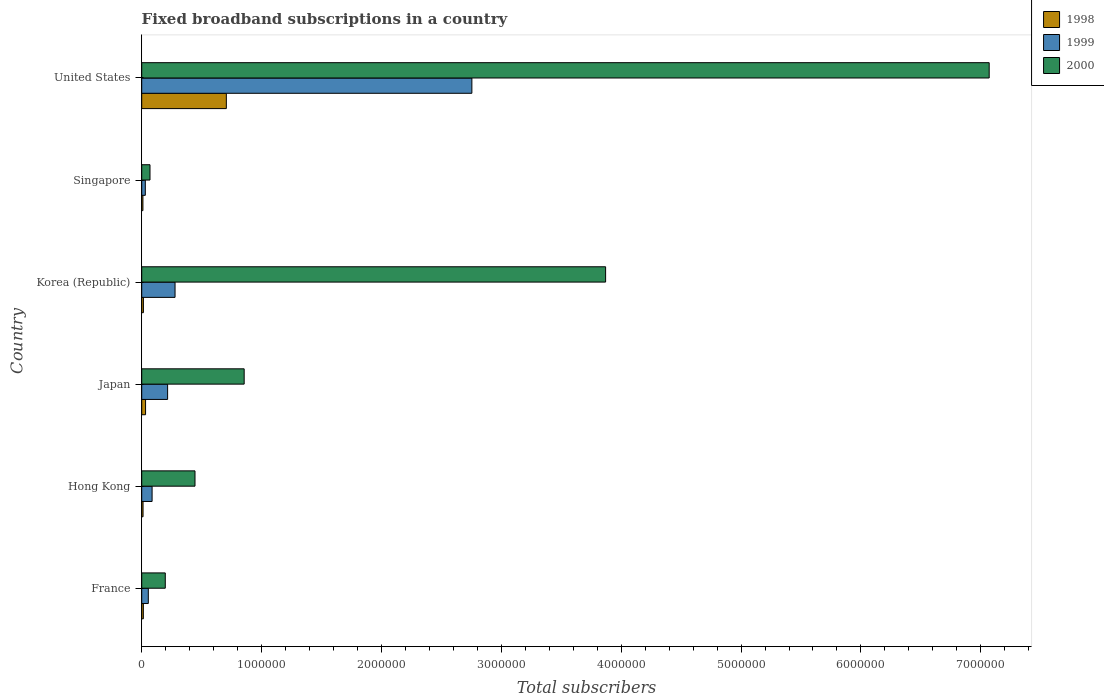How many groups of bars are there?
Provide a short and direct response. 6. Are the number of bars on each tick of the Y-axis equal?
Keep it short and to the point. Yes. How many bars are there on the 1st tick from the top?
Offer a very short reply. 3. How many bars are there on the 4th tick from the bottom?
Provide a succinct answer. 3. What is the number of broadband subscriptions in 1999 in Korea (Republic)?
Provide a short and direct response. 2.78e+05. Across all countries, what is the maximum number of broadband subscriptions in 2000?
Provide a succinct answer. 7.07e+06. Across all countries, what is the minimum number of broadband subscriptions in 2000?
Give a very brief answer. 6.90e+04. In which country was the number of broadband subscriptions in 1998 minimum?
Make the answer very short. Singapore. What is the total number of broadband subscriptions in 2000 in the graph?
Ensure brevity in your answer.  1.25e+07. What is the difference between the number of broadband subscriptions in 1998 in France and that in Korea (Republic)?
Your answer should be compact. -536. What is the difference between the number of broadband subscriptions in 2000 in Hong Kong and the number of broadband subscriptions in 1999 in Korea (Republic)?
Provide a succinct answer. 1.66e+05. What is the average number of broadband subscriptions in 2000 per country?
Give a very brief answer. 2.08e+06. What is the difference between the number of broadband subscriptions in 1999 and number of broadband subscriptions in 1998 in Singapore?
Your answer should be compact. 2.00e+04. In how many countries, is the number of broadband subscriptions in 2000 greater than 7200000 ?
Offer a terse response. 0. What is the ratio of the number of broadband subscriptions in 1998 in Hong Kong to that in Singapore?
Ensure brevity in your answer.  1.1. Is the number of broadband subscriptions in 1999 in Hong Kong less than that in Singapore?
Your response must be concise. No. What is the difference between the highest and the second highest number of broadband subscriptions in 1999?
Provide a short and direct response. 2.48e+06. What is the difference between the highest and the lowest number of broadband subscriptions in 1999?
Make the answer very short. 2.72e+06. In how many countries, is the number of broadband subscriptions in 1998 greater than the average number of broadband subscriptions in 1998 taken over all countries?
Offer a terse response. 1. What does the 1st bar from the bottom in United States represents?
Your answer should be very brief. 1998. How many bars are there?
Give a very brief answer. 18. How many countries are there in the graph?
Offer a terse response. 6. What is the difference between two consecutive major ticks on the X-axis?
Make the answer very short. 1.00e+06. Does the graph contain any zero values?
Keep it short and to the point. No. Does the graph contain grids?
Your answer should be very brief. No. How many legend labels are there?
Offer a terse response. 3. How are the legend labels stacked?
Provide a succinct answer. Vertical. What is the title of the graph?
Offer a terse response. Fixed broadband subscriptions in a country. What is the label or title of the X-axis?
Provide a succinct answer. Total subscribers. What is the Total subscribers of 1998 in France?
Your answer should be very brief. 1.35e+04. What is the Total subscribers in 1999 in France?
Offer a very short reply. 5.50e+04. What is the Total subscribers in 2000 in France?
Provide a succinct answer. 1.97e+05. What is the Total subscribers in 1998 in Hong Kong?
Your answer should be compact. 1.10e+04. What is the Total subscribers of 1999 in Hong Kong?
Your answer should be compact. 8.65e+04. What is the Total subscribers in 2000 in Hong Kong?
Your response must be concise. 4.44e+05. What is the Total subscribers in 1998 in Japan?
Provide a short and direct response. 3.20e+04. What is the Total subscribers in 1999 in Japan?
Your response must be concise. 2.16e+05. What is the Total subscribers in 2000 in Japan?
Your answer should be very brief. 8.55e+05. What is the Total subscribers of 1998 in Korea (Republic)?
Offer a very short reply. 1.40e+04. What is the Total subscribers of 1999 in Korea (Republic)?
Offer a terse response. 2.78e+05. What is the Total subscribers of 2000 in Korea (Republic)?
Make the answer very short. 3.87e+06. What is the Total subscribers of 1998 in Singapore?
Make the answer very short. 10000. What is the Total subscribers of 2000 in Singapore?
Give a very brief answer. 6.90e+04. What is the Total subscribers in 1998 in United States?
Your answer should be very brief. 7.06e+05. What is the Total subscribers of 1999 in United States?
Offer a very short reply. 2.75e+06. What is the Total subscribers in 2000 in United States?
Ensure brevity in your answer.  7.07e+06. Across all countries, what is the maximum Total subscribers of 1998?
Make the answer very short. 7.06e+05. Across all countries, what is the maximum Total subscribers in 1999?
Make the answer very short. 2.75e+06. Across all countries, what is the maximum Total subscribers of 2000?
Ensure brevity in your answer.  7.07e+06. Across all countries, what is the minimum Total subscribers of 1998?
Your response must be concise. 10000. Across all countries, what is the minimum Total subscribers of 1999?
Provide a short and direct response. 3.00e+04. Across all countries, what is the minimum Total subscribers in 2000?
Give a very brief answer. 6.90e+04. What is the total Total subscribers of 1998 in the graph?
Provide a short and direct response. 7.86e+05. What is the total Total subscribers of 1999 in the graph?
Provide a short and direct response. 3.42e+06. What is the total Total subscribers of 2000 in the graph?
Offer a terse response. 1.25e+07. What is the difference between the Total subscribers in 1998 in France and that in Hong Kong?
Offer a very short reply. 2464. What is the difference between the Total subscribers in 1999 in France and that in Hong Kong?
Offer a terse response. -3.15e+04. What is the difference between the Total subscribers of 2000 in France and that in Hong Kong?
Give a very brief answer. -2.48e+05. What is the difference between the Total subscribers of 1998 in France and that in Japan?
Provide a succinct answer. -1.85e+04. What is the difference between the Total subscribers of 1999 in France and that in Japan?
Offer a very short reply. -1.61e+05. What is the difference between the Total subscribers in 2000 in France and that in Japan?
Your answer should be compact. -6.58e+05. What is the difference between the Total subscribers in 1998 in France and that in Korea (Republic)?
Give a very brief answer. -536. What is the difference between the Total subscribers in 1999 in France and that in Korea (Republic)?
Offer a very short reply. -2.23e+05. What is the difference between the Total subscribers of 2000 in France and that in Korea (Republic)?
Provide a short and direct response. -3.67e+06. What is the difference between the Total subscribers of 1998 in France and that in Singapore?
Give a very brief answer. 3464. What is the difference between the Total subscribers of 1999 in France and that in Singapore?
Your answer should be very brief. 2.50e+04. What is the difference between the Total subscribers of 2000 in France and that in Singapore?
Keep it short and to the point. 1.28e+05. What is the difference between the Total subscribers of 1998 in France and that in United States?
Make the answer very short. -6.92e+05. What is the difference between the Total subscribers of 1999 in France and that in United States?
Ensure brevity in your answer.  -2.70e+06. What is the difference between the Total subscribers in 2000 in France and that in United States?
Offer a terse response. -6.87e+06. What is the difference between the Total subscribers in 1998 in Hong Kong and that in Japan?
Provide a short and direct response. -2.10e+04. What is the difference between the Total subscribers of 1999 in Hong Kong and that in Japan?
Provide a succinct answer. -1.30e+05. What is the difference between the Total subscribers of 2000 in Hong Kong and that in Japan?
Provide a succinct answer. -4.10e+05. What is the difference between the Total subscribers in 1998 in Hong Kong and that in Korea (Republic)?
Your answer should be very brief. -3000. What is the difference between the Total subscribers in 1999 in Hong Kong and that in Korea (Republic)?
Your response must be concise. -1.92e+05. What is the difference between the Total subscribers in 2000 in Hong Kong and that in Korea (Republic)?
Keep it short and to the point. -3.43e+06. What is the difference between the Total subscribers of 1999 in Hong Kong and that in Singapore?
Provide a short and direct response. 5.65e+04. What is the difference between the Total subscribers of 2000 in Hong Kong and that in Singapore?
Offer a terse response. 3.75e+05. What is the difference between the Total subscribers in 1998 in Hong Kong and that in United States?
Provide a succinct answer. -6.95e+05. What is the difference between the Total subscribers in 1999 in Hong Kong and that in United States?
Your response must be concise. -2.67e+06. What is the difference between the Total subscribers in 2000 in Hong Kong and that in United States?
Offer a terse response. -6.63e+06. What is the difference between the Total subscribers of 1998 in Japan and that in Korea (Republic)?
Your answer should be very brief. 1.80e+04. What is the difference between the Total subscribers in 1999 in Japan and that in Korea (Republic)?
Provide a short and direct response. -6.20e+04. What is the difference between the Total subscribers in 2000 in Japan and that in Korea (Republic)?
Provide a succinct answer. -3.02e+06. What is the difference between the Total subscribers of 1998 in Japan and that in Singapore?
Make the answer very short. 2.20e+04. What is the difference between the Total subscribers of 1999 in Japan and that in Singapore?
Keep it short and to the point. 1.86e+05. What is the difference between the Total subscribers of 2000 in Japan and that in Singapore?
Give a very brief answer. 7.86e+05. What is the difference between the Total subscribers in 1998 in Japan and that in United States?
Your answer should be very brief. -6.74e+05. What is the difference between the Total subscribers in 1999 in Japan and that in United States?
Provide a short and direct response. -2.54e+06. What is the difference between the Total subscribers of 2000 in Japan and that in United States?
Offer a very short reply. -6.22e+06. What is the difference between the Total subscribers of 1998 in Korea (Republic) and that in Singapore?
Your answer should be compact. 4000. What is the difference between the Total subscribers in 1999 in Korea (Republic) and that in Singapore?
Make the answer very short. 2.48e+05. What is the difference between the Total subscribers of 2000 in Korea (Republic) and that in Singapore?
Your answer should be compact. 3.80e+06. What is the difference between the Total subscribers of 1998 in Korea (Republic) and that in United States?
Offer a very short reply. -6.92e+05. What is the difference between the Total subscribers in 1999 in Korea (Republic) and that in United States?
Your answer should be compact. -2.48e+06. What is the difference between the Total subscribers in 2000 in Korea (Republic) and that in United States?
Offer a very short reply. -3.20e+06. What is the difference between the Total subscribers in 1998 in Singapore and that in United States?
Provide a succinct answer. -6.96e+05. What is the difference between the Total subscribers in 1999 in Singapore and that in United States?
Offer a terse response. -2.72e+06. What is the difference between the Total subscribers in 2000 in Singapore and that in United States?
Offer a terse response. -7.00e+06. What is the difference between the Total subscribers in 1998 in France and the Total subscribers in 1999 in Hong Kong?
Make the answer very short. -7.30e+04. What is the difference between the Total subscribers in 1998 in France and the Total subscribers in 2000 in Hong Kong?
Your answer should be compact. -4.31e+05. What is the difference between the Total subscribers in 1999 in France and the Total subscribers in 2000 in Hong Kong?
Offer a very short reply. -3.89e+05. What is the difference between the Total subscribers in 1998 in France and the Total subscribers in 1999 in Japan?
Offer a terse response. -2.03e+05. What is the difference between the Total subscribers in 1998 in France and the Total subscribers in 2000 in Japan?
Ensure brevity in your answer.  -8.41e+05. What is the difference between the Total subscribers of 1999 in France and the Total subscribers of 2000 in Japan?
Give a very brief answer. -8.00e+05. What is the difference between the Total subscribers of 1998 in France and the Total subscribers of 1999 in Korea (Republic)?
Make the answer very short. -2.65e+05. What is the difference between the Total subscribers of 1998 in France and the Total subscribers of 2000 in Korea (Republic)?
Provide a short and direct response. -3.86e+06. What is the difference between the Total subscribers of 1999 in France and the Total subscribers of 2000 in Korea (Republic)?
Provide a succinct answer. -3.82e+06. What is the difference between the Total subscribers in 1998 in France and the Total subscribers in 1999 in Singapore?
Give a very brief answer. -1.65e+04. What is the difference between the Total subscribers in 1998 in France and the Total subscribers in 2000 in Singapore?
Give a very brief answer. -5.55e+04. What is the difference between the Total subscribers of 1999 in France and the Total subscribers of 2000 in Singapore?
Your answer should be very brief. -1.40e+04. What is the difference between the Total subscribers of 1998 in France and the Total subscribers of 1999 in United States?
Your response must be concise. -2.74e+06. What is the difference between the Total subscribers in 1998 in France and the Total subscribers in 2000 in United States?
Your answer should be very brief. -7.06e+06. What is the difference between the Total subscribers in 1999 in France and the Total subscribers in 2000 in United States?
Offer a very short reply. -7.01e+06. What is the difference between the Total subscribers of 1998 in Hong Kong and the Total subscribers of 1999 in Japan?
Offer a terse response. -2.05e+05. What is the difference between the Total subscribers in 1998 in Hong Kong and the Total subscribers in 2000 in Japan?
Your answer should be compact. -8.44e+05. What is the difference between the Total subscribers of 1999 in Hong Kong and the Total subscribers of 2000 in Japan?
Ensure brevity in your answer.  -7.68e+05. What is the difference between the Total subscribers of 1998 in Hong Kong and the Total subscribers of 1999 in Korea (Republic)?
Ensure brevity in your answer.  -2.67e+05. What is the difference between the Total subscribers in 1998 in Hong Kong and the Total subscribers in 2000 in Korea (Republic)?
Provide a short and direct response. -3.86e+06. What is the difference between the Total subscribers of 1999 in Hong Kong and the Total subscribers of 2000 in Korea (Republic)?
Your response must be concise. -3.78e+06. What is the difference between the Total subscribers of 1998 in Hong Kong and the Total subscribers of 1999 in Singapore?
Provide a succinct answer. -1.90e+04. What is the difference between the Total subscribers in 1998 in Hong Kong and the Total subscribers in 2000 in Singapore?
Your response must be concise. -5.80e+04. What is the difference between the Total subscribers of 1999 in Hong Kong and the Total subscribers of 2000 in Singapore?
Ensure brevity in your answer.  1.75e+04. What is the difference between the Total subscribers of 1998 in Hong Kong and the Total subscribers of 1999 in United States?
Ensure brevity in your answer.  -2.74e+06. What is the difference between the Total subscribers in 1998 in Hong Kong and the Total subscribers in 2000 in United States?
Make the answer very short. -7.06e+06. What is the difference between the Total subscribers in 1999 in Hong Kong and the Total subscribers in 2000 in United States?
Offer a terse response. -6.98e+06. What is the difference between the Total subscribers in 1998 in Japan and the Total subscribers in 1999 in Korea (Republic)?
Provide a short and direct response. -2.46e+05. What is the difference between the Total subscribers of 1998 in Japan and the Total subscribers of 2000 in Korea (Republic)?
Provide a succinct answer. -3.84e+06. What is the difference between the Total subscribers in 1999 in Japan and the Total subscribers in 2000 in Korea (Republic)?
Provide a short and direct response. -3.65e+06. What is the difference between the Total subscribers in 1998 in Japan and the Total subscribers in 1999 in Singapore?
Your answer should be very brief. 2000. What is the difference between the Total subscribers in 1998 in Japan and the Total subscribers in 2000 in Singapore?
Offer a terse response. -3.70e+04. What is the difference between the Total subscribers in 1999 in Japan and the Total subscribers in 2000 in Singapore?
Provide a short and direct response. 1.47e+05. What is the difference between the Total subscribers of 1998 in Japan and the Total subscribers of 1999 in United States?
Offer a very short reply. -2.72e+06. What is the difference between the Total subscribers in 1998 in Japan and the Total subscribers in 2000 in United States?
Make the answer very short. -7.04e+06. What is the difference between the Total subscribers of 1999 in Japan and the Total subscribers of 2000 in United States?
Give a very brief answer. -6.85e+06. What is the difference between the Total subscribers in 1998 in Korea (Republic) and the Total subscribers in 1999 in Singapore?
Offer a very short reply. -1.60e+04. What is the difference between the Total subscribers of 1998 in Korea (Republic) and the Total subscribers of 2000 in Singapore?
Keep it short and to the point. -5.50e+04. What is the difference between the Total subscribers in 1999 in Korea (Republic) and the Total subscribers in 2000 in Singapore?
Keep it short and to the point. 2.09e+05. What is the difference between the Total subscribers of 1998 in Korea (Republic) and the Total subscribers of 1999 in United States?
Provide a succinct answer. -2.74e+06. What is the difference between the Total subscribers of 1998 in Korea (Republic) and the Total subscribers of 2000 in United States?
Keep it short and to the point. -7.06e+06. What is the difference between the Total subscribers of 1999 in Korea (Republic) and the Total subscribers of 2000 in United States?
Keep it short and to the point. -6.79e+06. What is the difference between the Total subscribers in 1998 in Singapore and the Total subscribers in 1999 in United States?
Offer a terse response. -2.74e+06. What is the difference between the Total subscribers of 1998 in Singapore and the Total subscribers of 2000 in United States?
Offer a very short reply. -7.06e+06. What is the difference between the Total subscribers in 1999 in Singapore and the Total subscribers in 2000 in United States?
Provide a short and direct response. -7.04e+06. What is the average Total subscribers in 1998 per country?
Keep it short and to the point. 1.31e+05. What is the average Total subscribers in 1999 per country?
Ensure brevity in your answer.  5.70e+05. What is the average Total subscribers in 2000 per country?
Offer a terse response. 2.08e+06. What is the difference between the Total subscribers in 1998 and Total subscribers in 1999 in France?
Your answer should be compact. -4.15e+04. What is the difference between the Total subscribers of 1998 and Total subscribers of 2000 in France?
Provide a short and direct response. -1.83e+05. What is the difference between the Total subscribers of 1999 and Total subscribers of 2000 in France?
Provide a short and direct response. -1.42e+05. What is the difference between the Total subscribers in 1998 and Total subscribers in 1999 in Hong Kong?
Offer a very short reply. -7.55e+04. What is the difference between the Total subscribers in 1998 and Total subscribers in 2000 in Hong Kong?
Give a very brief answer. -4.33e+05. What is the difference between the Total subscribers in 1999 and Total subscribers in 2000 in Hong Kong?
Provide a succinct answer. -3.58e+05. What is the difference between the Total subscribers of 1998 and Total subscribers of 1999 in Japan?
Ensure brevity in your answer.  -1.84e+05. What is the difference between the Total subscribers in 1998 and Total subscribers in 2000 in Japan?
Ensure brevity in your answer.  -8.23e+05. What is the difference between the Total subscribers of 1999 and Total subscribers of 2000 in Japan?
Ensure brevity in your answer.  -6.39e+05. What is the difference between the Total subscribers of 1998 and Total subscribers of 1999 in Korea (Republic)?
Provide a succinct answer. -2.64e+05. What is the difference between the Total subscribers in 1998 and Total subscribers in 2000 in Korea (Republic)?
Offer a very short reply. -3.86e+06. What is the difference between the Total subscribers of 1999 and Total subscribers of 2000 in Korea (Republic)?
Ensure brevity in your answer.  -3.59e+06. What is the difference between the Total subscribers in 1998 and Total subscribers in 1999 in Singapore?
Make the answer very short. -2.00e+04. What is the difference between the Total subscribers in 1998 and Total subscribers in 2000 in Singapore?
Your response must be concise. -5.90e+04. What is the difference between the Total subscribers of 1999 and Total subscribers of 2000 in Singapore?
Offer a terse response. -3.90e+04. What is the difference between the Total subscribers in 1998 and Total subscribers in 1999 in United States?
Keep it short and to the point. -2.05e+06. What is the difference between the Total subscribers of 1998 and Total subscribers of 2000 in United States?
Make the answer very short. -6.36e+06. What is the difference between the Total subscribers in 1999 and Total subscribers in 2000 in United States?
Provide a short and direct response. -4.32e+06. What is the ratio of the Total subscribers of 1998 in France to that in Hong Kong?
Give a very brief answer. 1.22. What is the ratio of the Total subscribers of 1999 in France to that in Hong Kong?
Keep it short and to the point. 0.64. What is the ratio of the Total subscribers of 2000 in France to that in Hong Kong?
Offer a terse response. 0.44. What is the ratio of the Total subscribers in 1998 in France to that in Japan?
Offer a very short reply. 0.42. What is the ratio of the Total subscribers in 1999 in France to that in Japan?
Offer a very short reply. 0.25. What is the ratio of the Total subscribers of 2000 in France to that in Japan?
Ensure brevity in your answer.  0.23. What is the ratio of the Total subscribers of 1998 in France to that in Korea (Republic)?
Provide a short and direct response. 0.96. What is the ratio of the Total subscribers of 1999 in France to that in Korea (Republic)?
Provide a succinct answer. 0.2. What is the ratio of the Total subscribers of 2000 in France to that in Korea (Republic)?
Provide a succinct answer. 0.05. What is the ratio of the Total subscribers in 1998 in France to that in Singapore?
Your response must be concise. 1.35. What is the ratio of the Total subscribers of 1999 in France to that in Singapore?
Provide a short and direct response. 1.83. What is the ratio of the Total subscribers of 2000 in France to that in Singapore?
Offer a very short reply. 2.85. What is the ratio of the Total subscribers of 1998 in France to that in United States?
Your response must be concise. 0.02. What is the ratio of the Total subscribers in 1999 in France to that in United States?
Your response must be concise. 0.02. What is the ratio of the Total subscribers of 2000 in France to that in United States?
Give a very brief answer. 0.03. What is the ratio of the Total subscribers of 1998 in Hong Kong to that in Japan?
Offer a very short reply. 0.34. What is the ratio of the Total subscribers of 1999 in Hong Kong to that in Japan?
Give a very brief answer. 0.4. What is the ratio of the Total subscribers in 2000 in Hong Kong to that in Japan?
Your answer should be compact. 0.52. What is the ratio of the Total subscribers of 1998 in Hong Kong to that in Korea (Republic)?
Keep it short and to the point. 0.79. What is the ratio of the Total subscribers of 1999 in Hong Kong to that in Korea (Republic)?
Provide a succinct answer. 0.31. What is the ratio of the Total subscribers in 2000 in Hong Kong to that in Korea (Republic)?
Provide a succinct answer. 0.11. What is the ratio of the Total subscribers in 1999 in Hong Kong to that in Singapore?
Keep it short and to the point. 2.88. What is the ratio of the Total subscribers in 2000 in Hong Kong to that in Singapore?
Give a very brief answer. 6.44. What is the ratio of the Total subscribers in 1998 in Hong Kong to that in United States?
Ensure brevity in your answer.  0.02. What is the ratio of the Total subscribers in 1999 in Hong Kong to that in United States?
Ensure brevity in your answer.  0.03. What is the ratio of the Total subscribers of 2000 in Hong Kong to that in United States?
Your answer should be very brief. 0.06. What is the ratio of the Total subscribers of 1998 in Japan to that in Korea (Republic)?
Ensure brevity in your answer.  2.29. What is the ratio of the Total subscribers of 1999 in Japan to that in Korea (Republic)?
Provide a short and direct response. 0.78. What is the ratio of the Total subscribers in 2000 in Japan to that in Korea (Republic)?
Provide a short and direct response. 0.22. What is the ratio of the Total subscribers in 1998 in Japan to that in Singapore?
Keep it short and to the point. 3.2. What is the ratio of the Total subscribers of 1999 in Japan to that in Singapore?
Make the answer very short. 7.2. What is the ratio of the Total subscribers of 2000 in Japan to that in Singapore?
Offer a very short reply. 12.39. What is the ratio of the Total subscribers in 1998 in Japan to that in United States?
Keep it short and to the point. 0.05. What is the ratio of the Total subscribers in 1999 in Japan to that in United States?
Your answer should be very brief. 0.08. What is the ratio of the Total subscribers of 2000 in Japan to that in United States?
Provide a short and direct response. 0.12. What is the ratio of the Total subscribers in 1999 in Korea (Republic) to that in Singapore?
Offer a terse response. 9.27. What is the ratio of the Total subscribers of 2000 in Korea (Republic) to that in Singapore?
Offer a very short reply. 56.09. What is the ratio of the Total subscribers of 1998 in Korea (Republic) to that in United States?
Offer a very short reply. 0.02. What is the ratio of the Total subscribers in 1999 in Korea (Republic) to that in United States?
Ensure brevity in your answer.  0.1. What is the ratio of the Total subscribers of 2000 in Korea (Republic) to that in United States?
Your answer should be very brief. 0.55. What is the ratio of the Total subscribers in 1998 in Singapore to that in United States?
Provide a succinct answer. 0.01. What is the ratio of the Total subscribers in 1999 in Singapore to that in United States?
Your answer should be very brief. 0.01. What is the ratio of the Total subscribers in 2000 in Singapore to that in United States?
Your response must be concise. 0.01. What is the difference between the highest and the second highest Total subscribers in 1998?
Your answer should be very brief. 6.74e+05. What is the difference between the highest and the second highest Total subscribers of 1999?
Give a very brief answer. 2.48e+06. What is the difference between the highest and the second highest Total subscribers of 2000?
Offer a very short reply. 3.20e+06. What is the difference between the highest and the lowest Total subscribers in 1998?
Offer a terse response. 6.96e+05. What is the difference between the highest and the lowest Total subscribers of 1999?
Provide a succinct answer. 2.72e+06. What is the difference between the highest and the lowest Total subscribers of 2000?
Provide a succinct answer. 7.00e+06. 